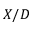Convert formula to latex. <formula><loc_0><loc_0><loc_500><loc_500>X / D</formula> 